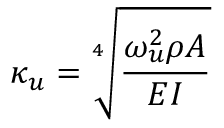<formula> <loc_0><loc_0><loc_500><loc_500>\kappa _ { u } = \sqrt { [ } 4 ] { \frac { \omega _ { u } ^ { 2 } \rho A } { E I } }</formula> 